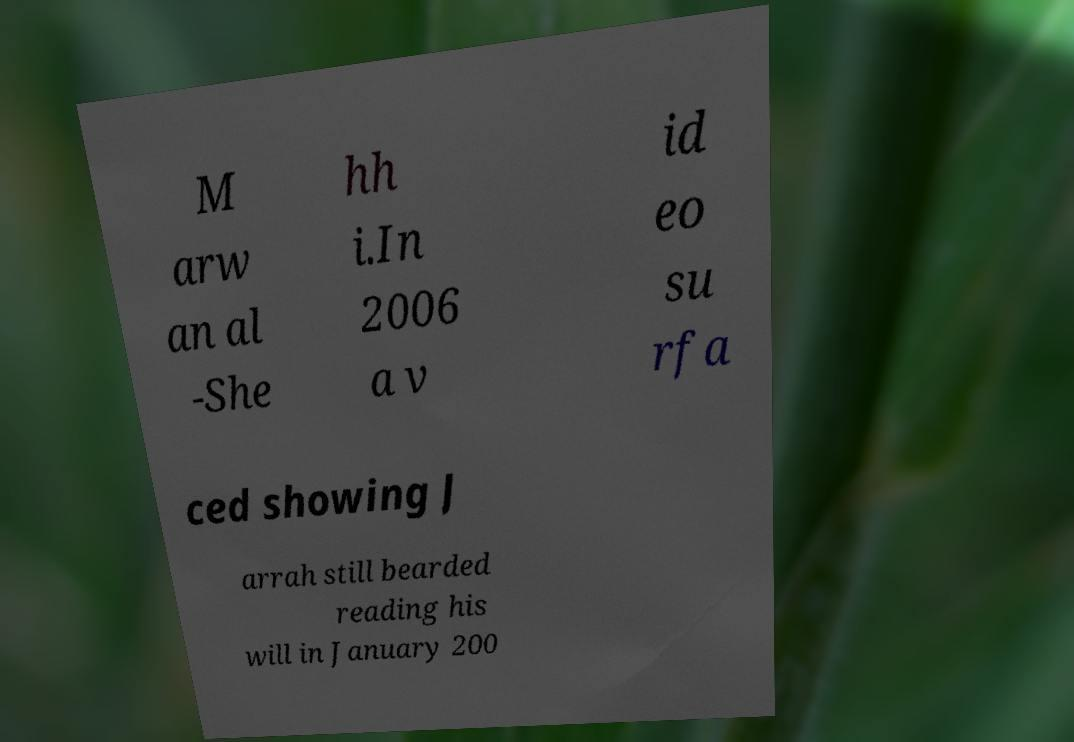Can you read and provide the text displayed in the image?This photo seems to have some interesting text. Can you extract and type it out for me? M arw an al -She hh i.In 2006 a v id eo su rfa ced showing J arrah still bearded reading his will in January 200 